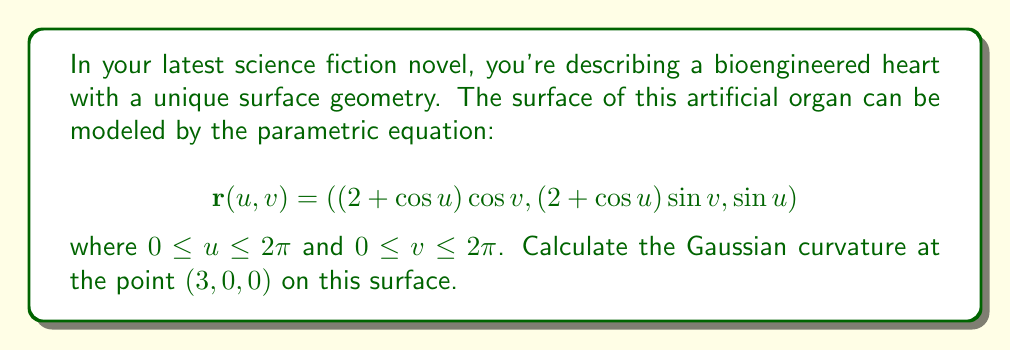Provide a solution to this math problem. To calculate the Gaussian curvature, we need to follow these steps:

1) First, we need to find the partial derivatives $\mathbf{r}_u$ and $\mathbf{r}_v$:

   $$\mathbf{r}_u = (-\sin u \cos v, -\sin u \sin v, \cos u)$$
   $$\mathbf{r}_v = (-(2+\cos u)\sin v, (2+\cos u)\cos v, 0)$$

2) Next, we calculate the coefficients of the first fundamental form:

   $$E = \mathbf{r}_u \cdot \mathbf{r}_u = \sin^2 u \cos^2 v + \sin^2 u \sin^2 v + \cos^2 u = 1$$
   $$F = \mathbf{r}_u \cdot \mathbf{r}_v = 0$$
   $$G = \mathbf{r}_v \cdot \mathbf{r}_v = (2+\cos u)^2$$

3) Now, we need the second partial derivatives:

   $$\mathbf{r}_{uu} = (-\cos u \cos v, -\cos u \sin v, -\sin u)$$
   $$\mathbf{r}_{uv} = (\sin u \sin v, -\sin u \cos v, 0)$$
   $$\mathbf{r}_{vv} = (-(2+\cos u)\cos v, -(2+\cos u)\sin v, 0)$$

4) We can now calculate the coefficients of the second fundamental form. For this, we need the unit normal vector:

   $$\mathbf{N} = \frac{\mathbf{r}_u \times \mathbf{r}_v}{|\mathbf{r}_u \times \mathbf{r}_v|} = \frac{((2+\cos u)\cos u \cos v, (2+\cos u)\cos u \sin v, -(2+\cos u)\sin u)}{\sqrt{(2+\cos u)^2}}$$

   Now we can calculate:

   $$L = \mathbf{r}_{uu} \cdot \mathbf{N} = \frac{2+\cos u}{\sqrt{(2+\cos u)^2}}$$
   $$M = \mathbf{r}_{uv} \cdot \mathbf{N} = 0$$
   $$N = \mathbf{r}_{vv} \cdot \mathbf{N} = \frac{(2+\cos u)\cos u}{\sqrt{(2+\cos u)^2}}$$

5) The Gaussian curvature is given by:

   $$K = \frac{LN-M^2}{EG-F^2} = \frac{L}{G} \cdot \frac{N}{E} = \frac{\cos u}{(2+\cos u)^2}$$

6) At the point $(3,0,0)$, we have $u=0$ and $v=0$. Substituting this into our expression for $K$:

   $$K = \frac{\cos 0}{(2+\cos 0)^2} = \frac{1}{3^2} = \frac{1}{9}$$

Therefore, the Gaussian curvature at the point $(3,0,0)$ is $\frac{1}{9}$.
Answer: $\frac{1}{9}$ 